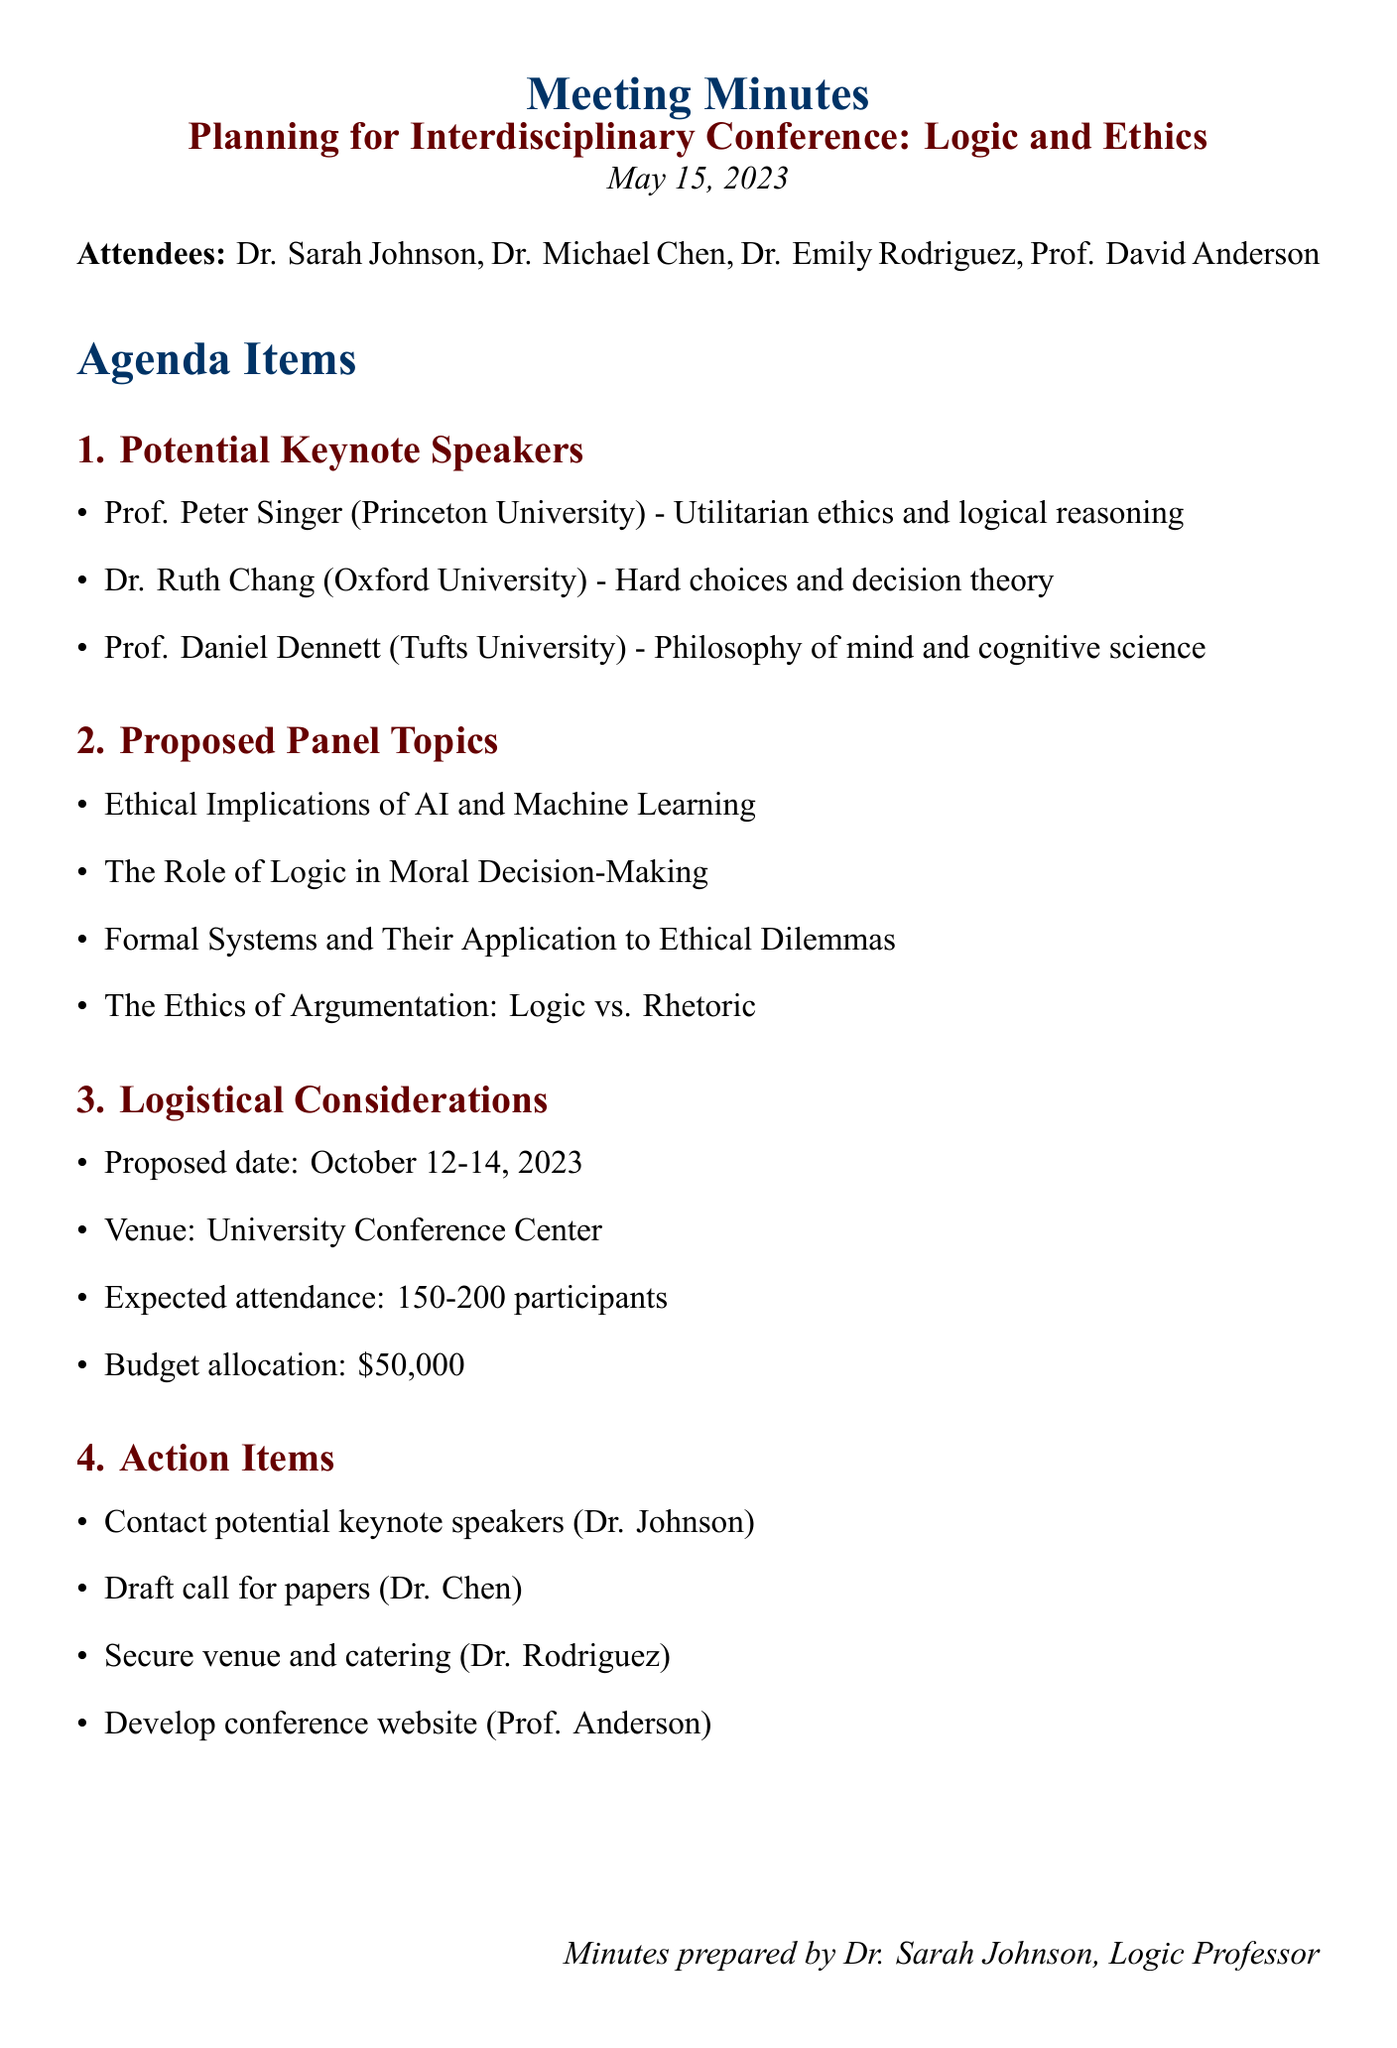What is the proposed date for the conference? The proposed date for the conference is mentioned in the logistical considerations section of the document.
Answer: October 12-14, 2023 Who is one of the potential keynote speakers from Princeton University? The document lists potential keynote speakers, including their affiliations and areas of expertise.
Answer: Prof. Peter Singer What is the expected attendance for the conference? The expected attendance is mentioned under logistical considerations, which gives a numerical estimate of participants.
Answer: 150-200 participants What is one of the proposed panel topics related to AI? The document includes several proposed panel topics, including those directly addressing modern ethical challenges.
Answer: Ethical Implications of AI and Machine Learning Which professor is responsible for drafting the call for papers? The action items list assigns specific tasks to attendees, identifying who is responsible for each task.
Answer: Dr. Chen How much is the budget allocation for the conference? The budget allocation is specified in the logistical considerations section, providing a clear financial framework for the event.
Answer: $50,000 What university is Dr. Ruth Chang affiliated with? The affiliations of potential keynote speakers are noted in the document, highlighting their respective institutions.
Answer: Oxford University What is one topic that explores the relationship between logic and ethics? The proposed panel topics section presents various discussions, covering intersections between logic and ethical theory.
Answer: The Role of Logic in Moral Decision-Making 